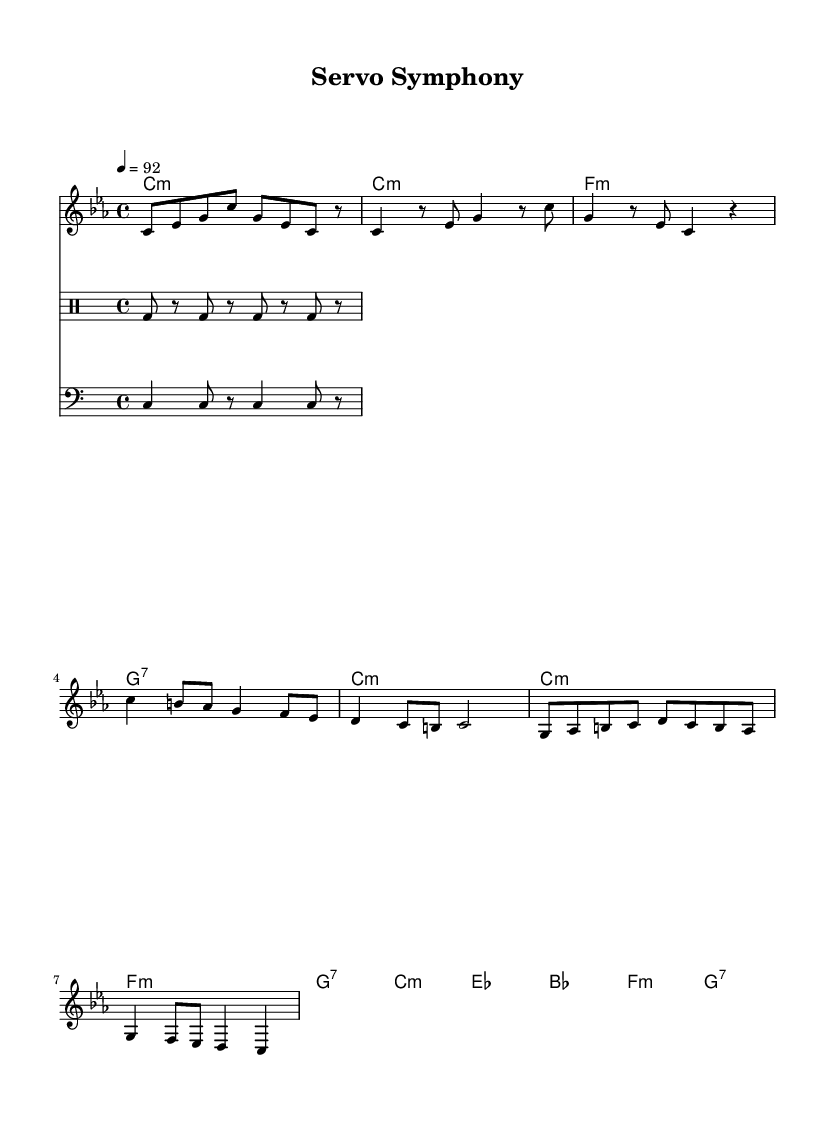What is the key signature of this music? The key signature is C minor, indicated by the three flats in the key signature line at the beginning of the sheet music.
Answer: C minor What is the time signature of this music? The time signature is 4/4, which is shown at the beginning of the sheet music directly after the key signature. This indicates four beats per measure, with a quarter note getting one beat.
Answer: 4/4 What is the tempo marking for this piece? The tempo is marked as 92 beats per minute, indicated by the text "4 = 92" in the tempo line towards the beginning of the sheet music.
Answer: 92 How many measures are in the verse section? The verse section consists of 8 measures, as counted through the melody line where this section occurs after the introduction.
Answer: 8 What is the main chord used in the introduction? The main chord in the introduction is C minor, clearly noted as the first chord in the harmony section which sets the tone for the piece.
Answer: C minor How does the drum pattern contribute to the overall feel of the rap? The drum pattern is characterized by a consistent kick on the beats, providing a driving rhythm typical in rap music, which helps to emphasize the lyrical flow, creating a foundational beat for the verses.
Answer: Driving rhythm What is the function of the bridge in this piece? The bridge serves as a contrasting section, allowing for a transition from the main themes presented in the verse and chorus, adding variety and enhancing the dynamics of the song structure.
Answer: Contrast 